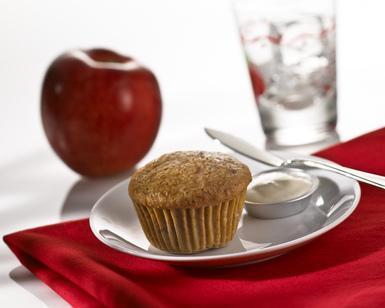How many plates?
Give a very brief answer. 1. 